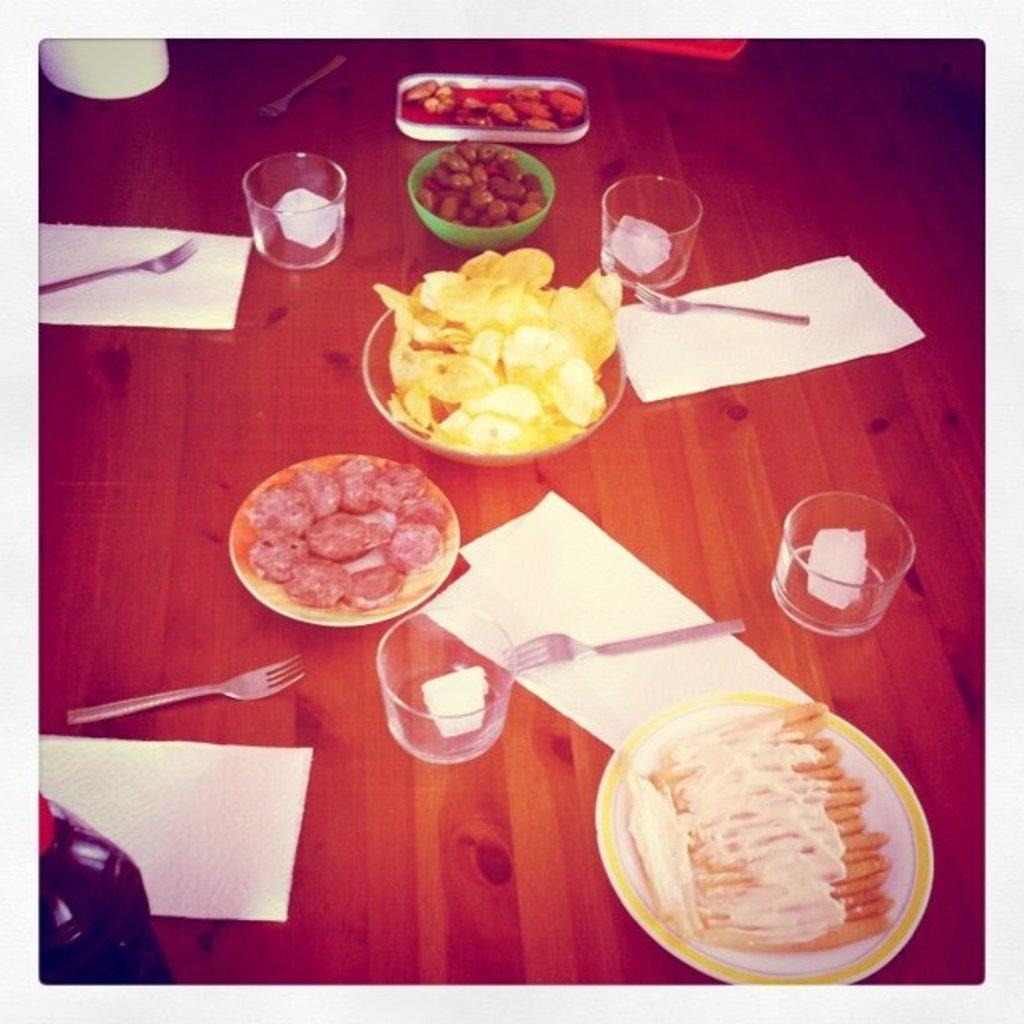What type of furniture is visible in the image? There is a table in the image. What items can be seen on the table? Glasses, plates, bowls, forks, tissue papers, and food items are present on the table. What might be used for eating the food items on the table? Forks are present on the table for eating the food items. What might be used for cleaning or wiping in the image? Tissue papers are present on the table for cleaning or wiping. What type of collar can be seen on the spot in the image? There is no collar or spot present in the image; it features a table with various items on it. 